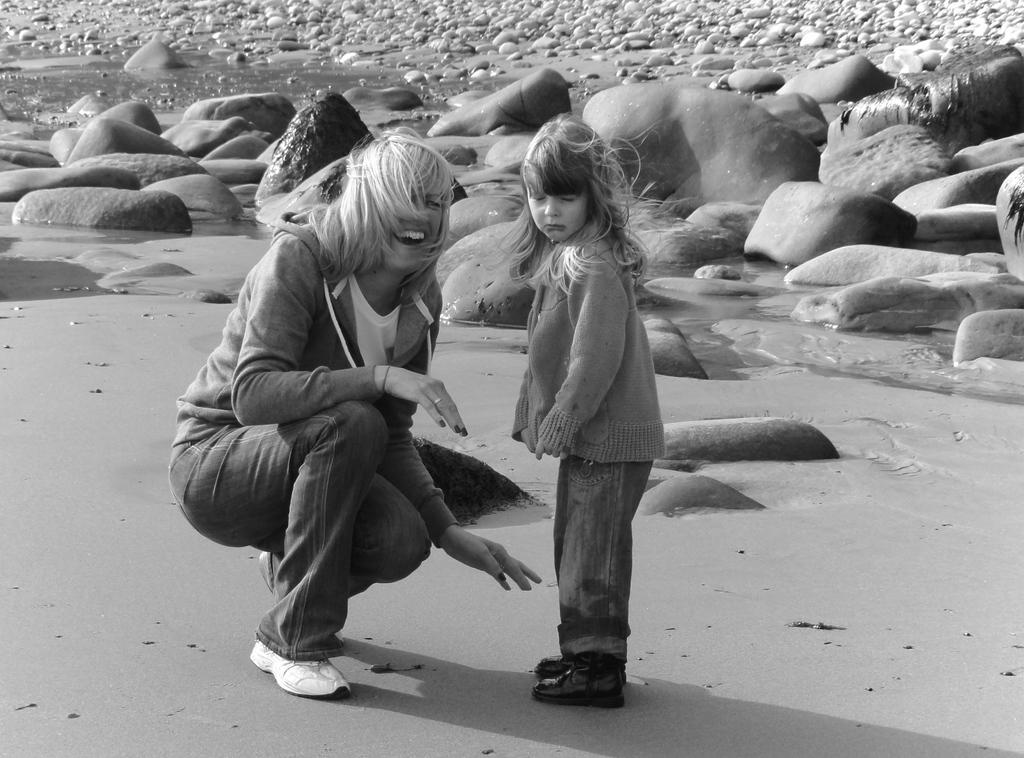Who is present in the image? There is a person and a kid in the image. What are they wearing? Both the person and the kid are wearing clothes. What can be seen at the top of the image? There are rocks at the top of the image. What type of loaf is being sliced by the person in the image? There is no loaf present in the image; it only features a person, a kid, and rocks. What flavor of juice is the kid drinking in the image? There is no juice present in the image; the only beverage mentioned is ice cream. 